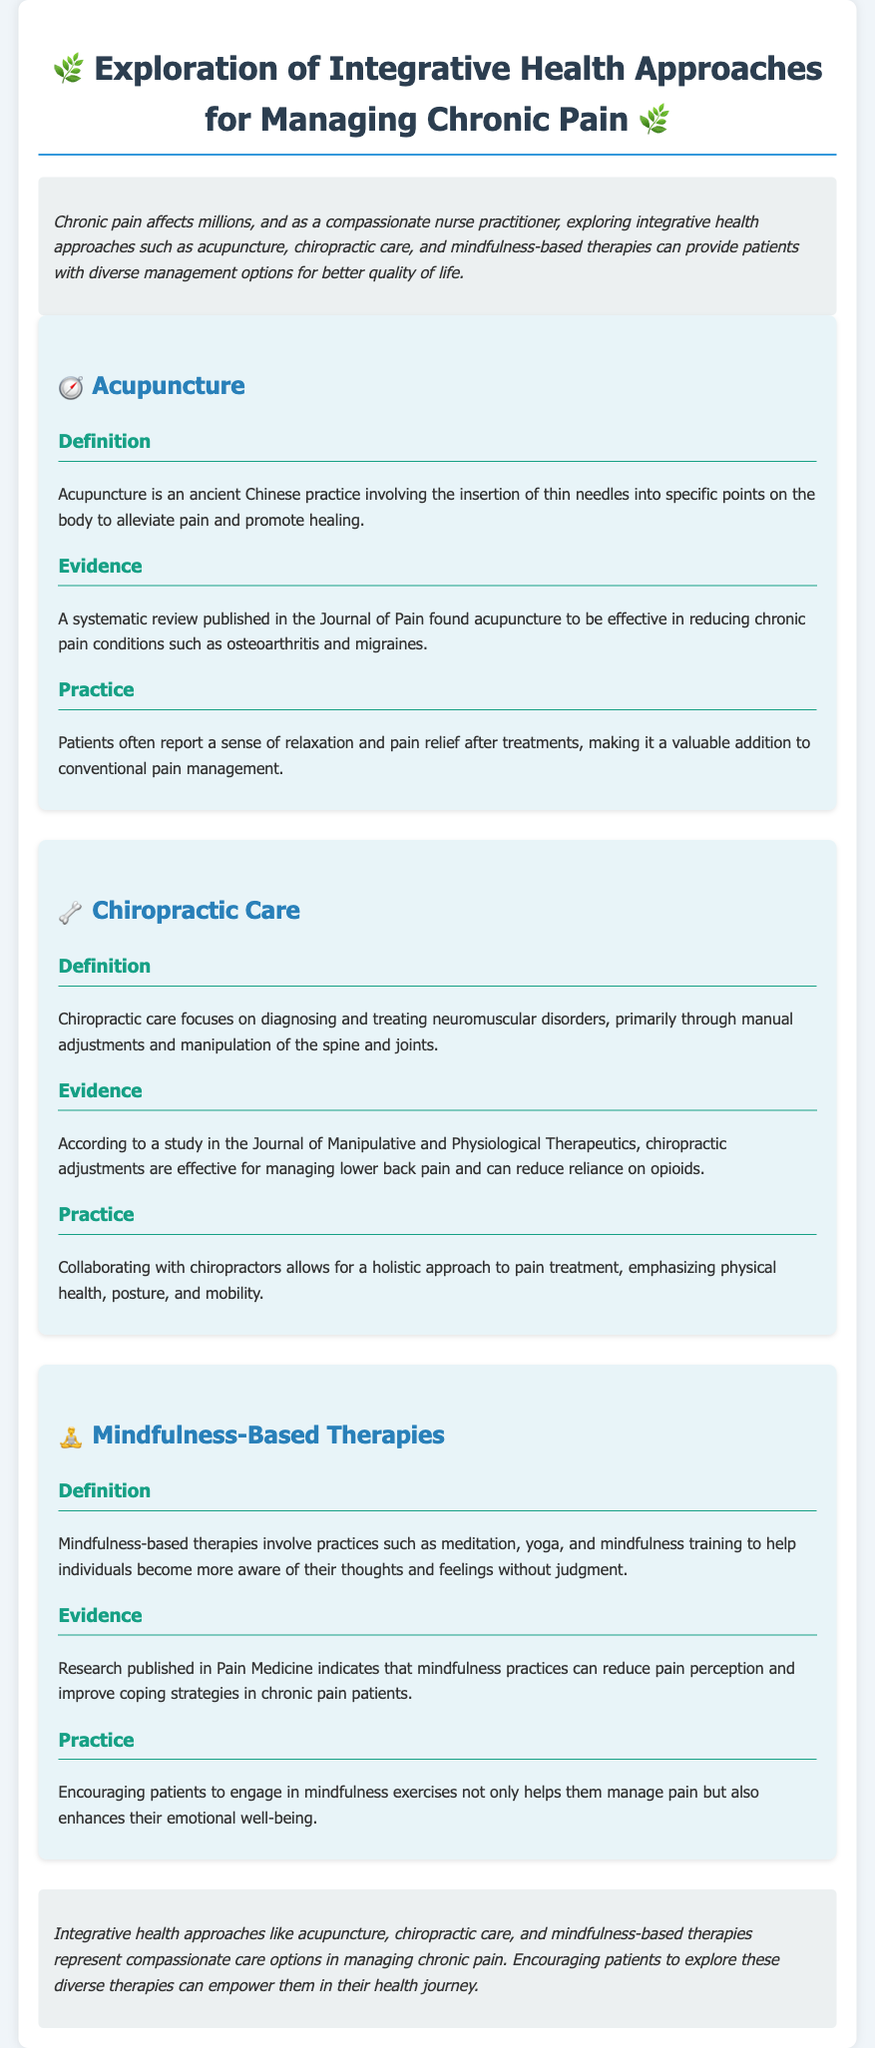What is acupuncture? Acupuncture is an ancient Chinese practice involving the insertion of thin needles into specific points on the body to alleviate pain and promote healing.
Answer: an ancient Chinese practice What evidence supports acupuncture's effectiveness? A systematic review published in the Journal of Pain found acupuncture to be effective in reducing chronic pain conditions such as osteoarthritis and migraines.
Answer: effective in reducing chronic pain What focus does chiropractic care have? Chiropractic care focuses on diagnosing and treating neuromuscular disorders, primarily through manual adjustments and manipulation of the spine and joints.
Answer: diagnosing and treating neuromuscular disorders Which journal published research regarding mindfulness-based therapies? Research published in Pain Medicine indicates that mindfulness practices can reduce pain perception and improve coping strategies in chronic pain patients.
Answer: Pain Medicine What are the key practices involved in mindfulness-based therapies? Mindfulness-based therapies involve practices such as meditation, yoga, and mindfulness training to help individuals become more aware of their thoughts and feelings without judgment.
Answer: meditation, yoga, and mindfulness training How can chiropractic adjustments impact opioid reliance? According to a study in the Journal of Manipulative and Physiological Therapeutics, chiropractic adjustments are effective for managing lower back pain and can reduce reliance on opioids.
Answer: reduce reliance on opioids What is the overall conclusion about integrative health approaches? Integrative health approaches like acupuncture, chiropractic care, and mindfulness-based therapies represent compassionate care options in managing chronic pain.
Answer: compassionate care options What symptoms can acupuncture alleviate? Acupuncture can alleviate conditions such as osteoarthritis and migraines.
Answer: osteoarthritis and migraines Why is collaboration with chiropractors emphasized? Collaborating with chiropractors allows for a holistic approach to pain treatment, emphasizing physical health, posture, and mobility.
Answer: a holistic approach to pain treatment 